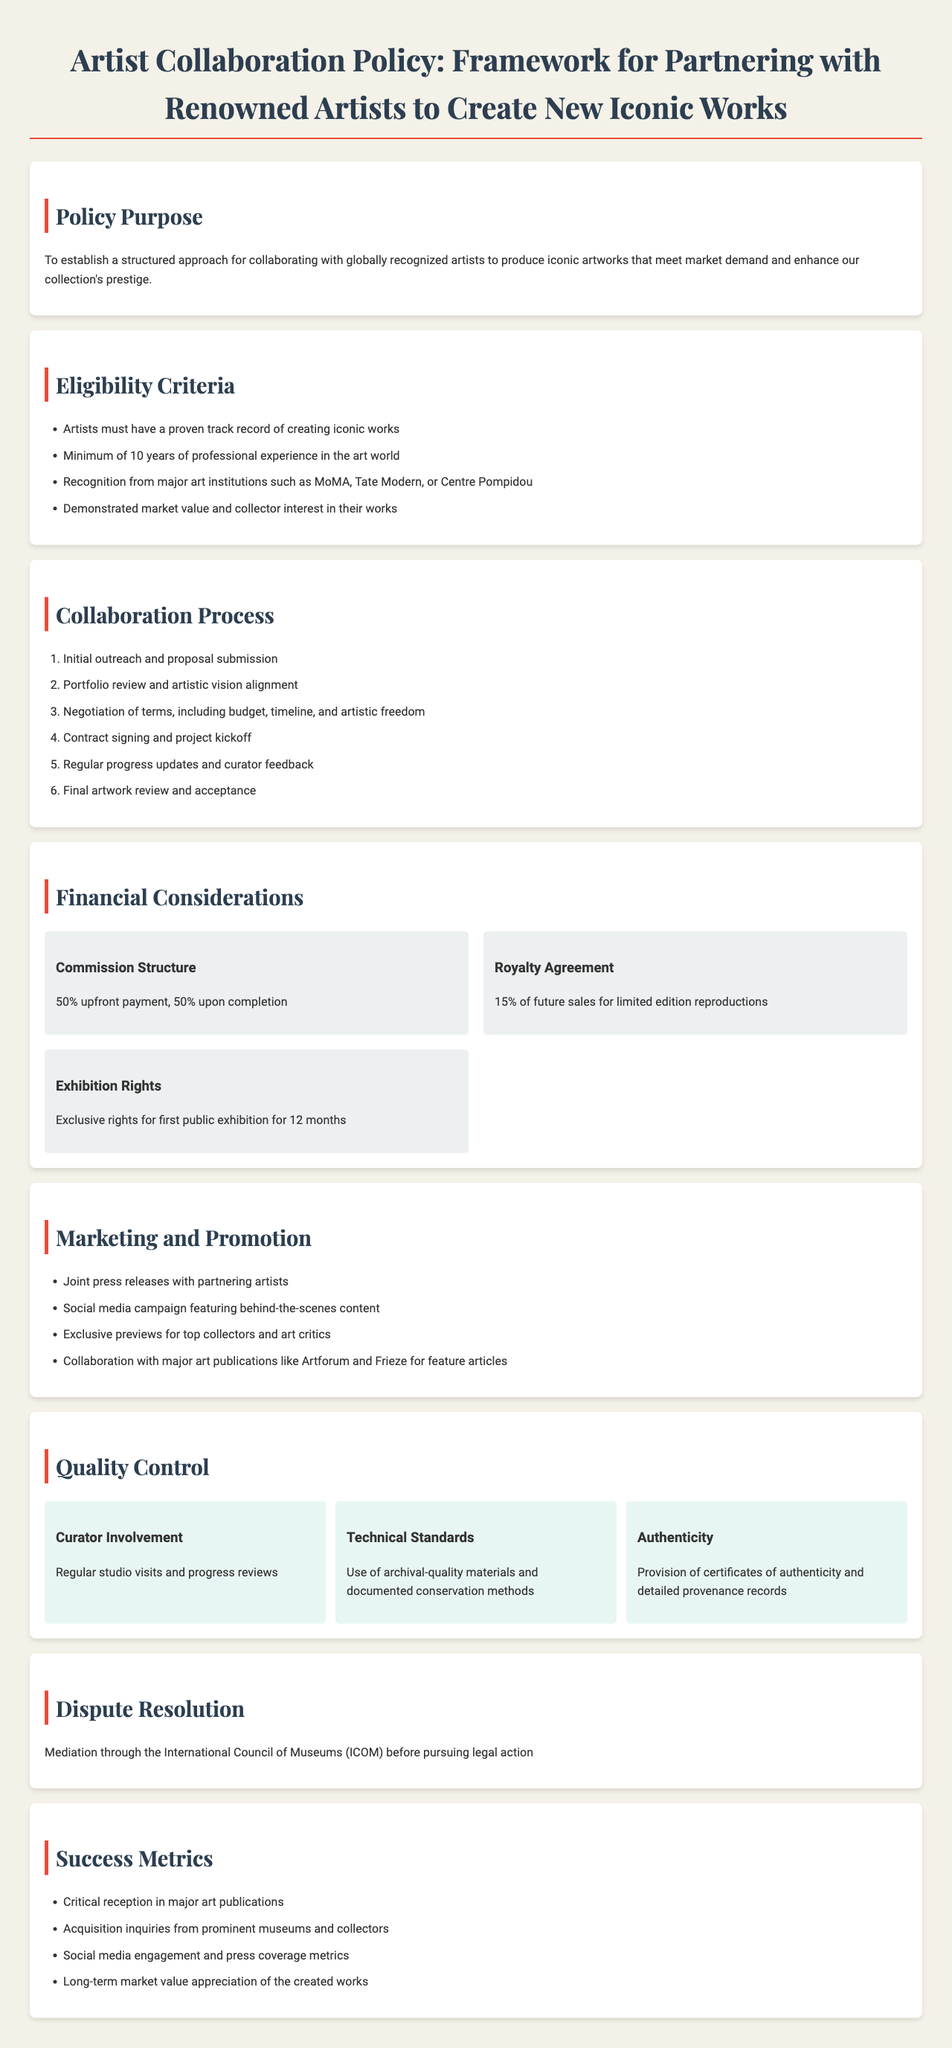What is the purpose of the Artist Collaboration Policy? The purpose is to establish a structured approach for collaborating with globally recognized artists to produce iconic artworks that meet market demand and enhance our collection's prestige.
Answer: To establish a structured approach for collaborating with globally recognized artists What is the minimum professional experience required for artists? The document states that artists must have a minimum of 10 years of professional experience in the art world.
Answer: 10 years What is the commission structure for collaborating artists? The document specifies a commission structure of 50% upfront payment and 50% upon completion.
Answer: 50% upfront payment, 50% upon completion What are the exhibition rights specified in the policy? The policy states that there are exclusive rights for the first public exhibition for 12 months.
Answer: 12 months What are the success metrics mentioned in the document? The success metrics include critical reception in major art publications, acquisition inquiries, social media engagement, and long-term market value appreciation.
Answer: Critical reception in major art publications What institution is involved in dispute resolution? The policy mentions mediation through the International Council of Museums (ICOM) before pursuing legal action.
Answer: International Council of Museums (ICOM) What is included in the quality control measures? The quality control measures include regular studio visits, use of archival-quality materials, and provision of certificates of authenticity.
Answer: Regular studio visits and progress reviews How long must an artist have a proven track record? The document requires artists to have a proven track record of creating iconic works, which implies a significant length but does not specify a duration.
Answer: Proven track record What is the percentage of royalties from future sales? The artist will receive 15% of future sales for limited edition reproductions according to the policy.
Answer: 15% 